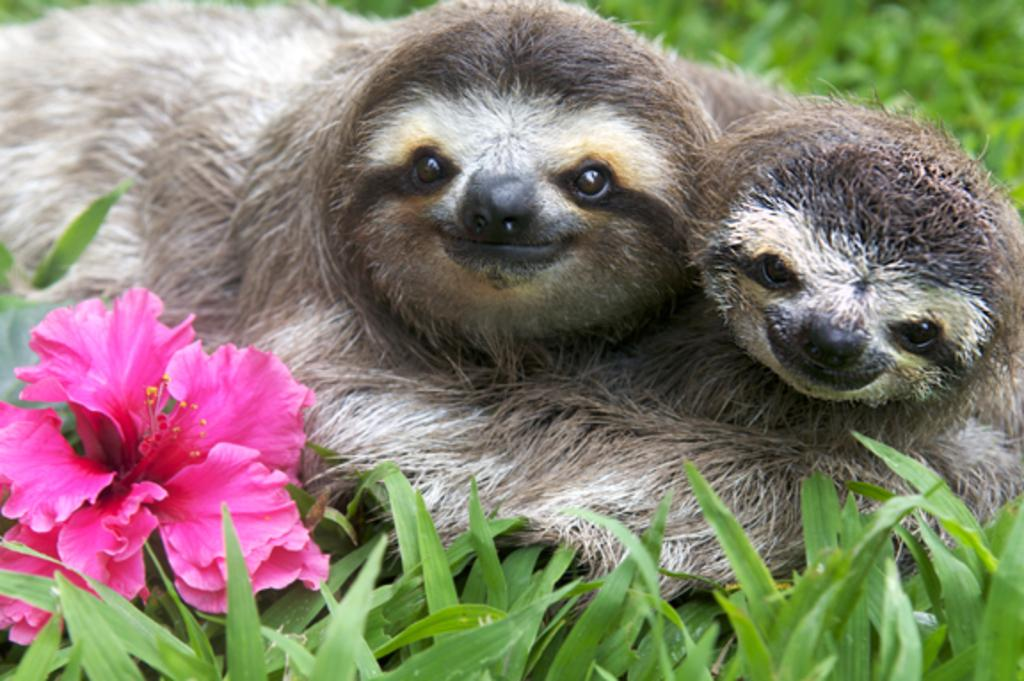How many animals are present in the image? There are two animals in the image. Where are the animals located? The animals are on the ground in the image. What other objects can be seen in the image besides the animals? There is a flower, a green object that looks like a leaf, and grass on the ground in the image. What is the condition of the background in the image? The background of the image is blurred. What type of elbow can be seen in the image? There is no elbow present in the image; it features two animals, a flower, a leaf, grass, and a blurred background. 